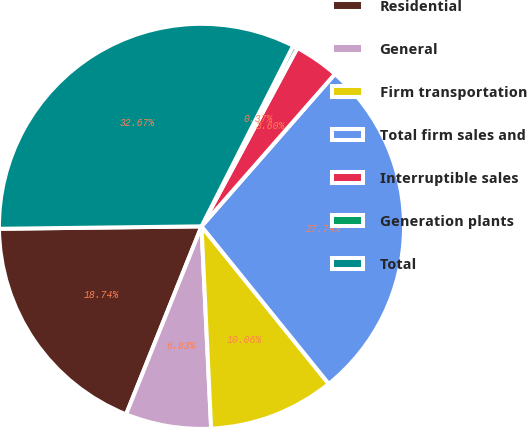Convert chart to OTSL. <chart><loc_0><loc_0><loc_500><loc_500><pie_chart><fcel>Residential<fcel>General<fcel>Firm transportation<fcel>Total firm sales and<fcel>Interruptible sales<fcel>Generation plants<fcel>Total<nl><fcel>18.74%<fcel>6.83%<fcel>10.06%<fcel>27.74%<fcel>3.6%<fcel>0.37%<fcel>32.67%<nl></chart> 